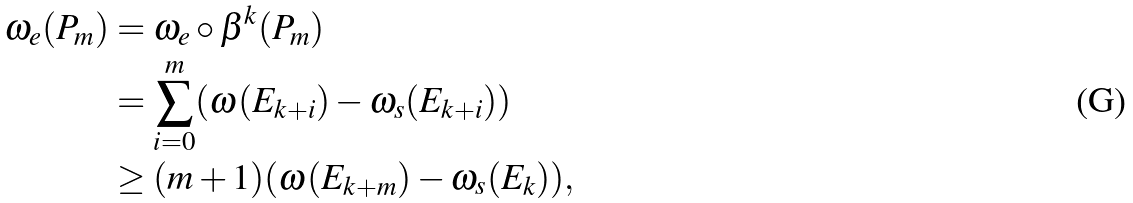<formula> <loc_0><loc_0><loc_500><loc_500>\omega _ { e } ( P _ { m } ) & = \omega _ { e } \circ \beta ^ { k } ( P _ { m } ) \\ & = \sum _ { i = 0 } ^ { m } ( \omega ( E _ { k + i } ) - \omega _ { s } ( E _ { k + i } ) ) \\ & \geq ( m + 1 ) ( \omega ( E _ { k + m } ) - \omega _ { s } ( E _ { k } ) ) ,</formula> 